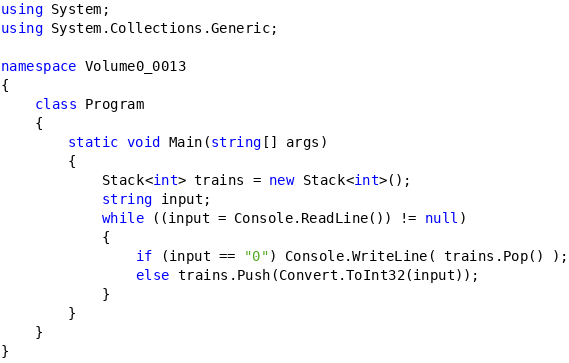Convert code to text. <code><loc_0><loc_0><loc_500><loc_500><_C#_>using System;
using System.Collections.Generic;

namespace Volume0_0013
{
    class Program
    {
        static void Main(string[] args)
        {
            Stack<int> trains = new Stack<int>();
            string input;
            while ((input = Console.ReadLine()) != null)
            {
                if (input == "0") Console.WriteLine( trains.Pop() );
                else trains.Push(Convert.ToInt32(input)); 
            }
        }
    }
}</code> 